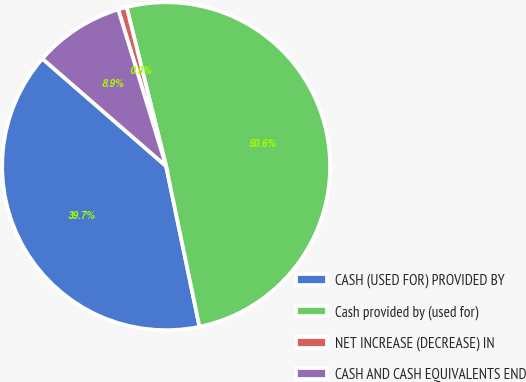<chart> <loc_0><loc_0><loc_500><loc_500><pie_chart><fcel>CASH (USED FOR) PROVIDED BY<fcel>Cash provided by (used for)<fcel>NET INCREASE (DECREASE) IN<fcel>CASH AND CASH EQUIVALENTS END<nl><fcel>39.65%<fcel>50.61%<fcel>0.85%<fcel>8.89%<nl></chart> 